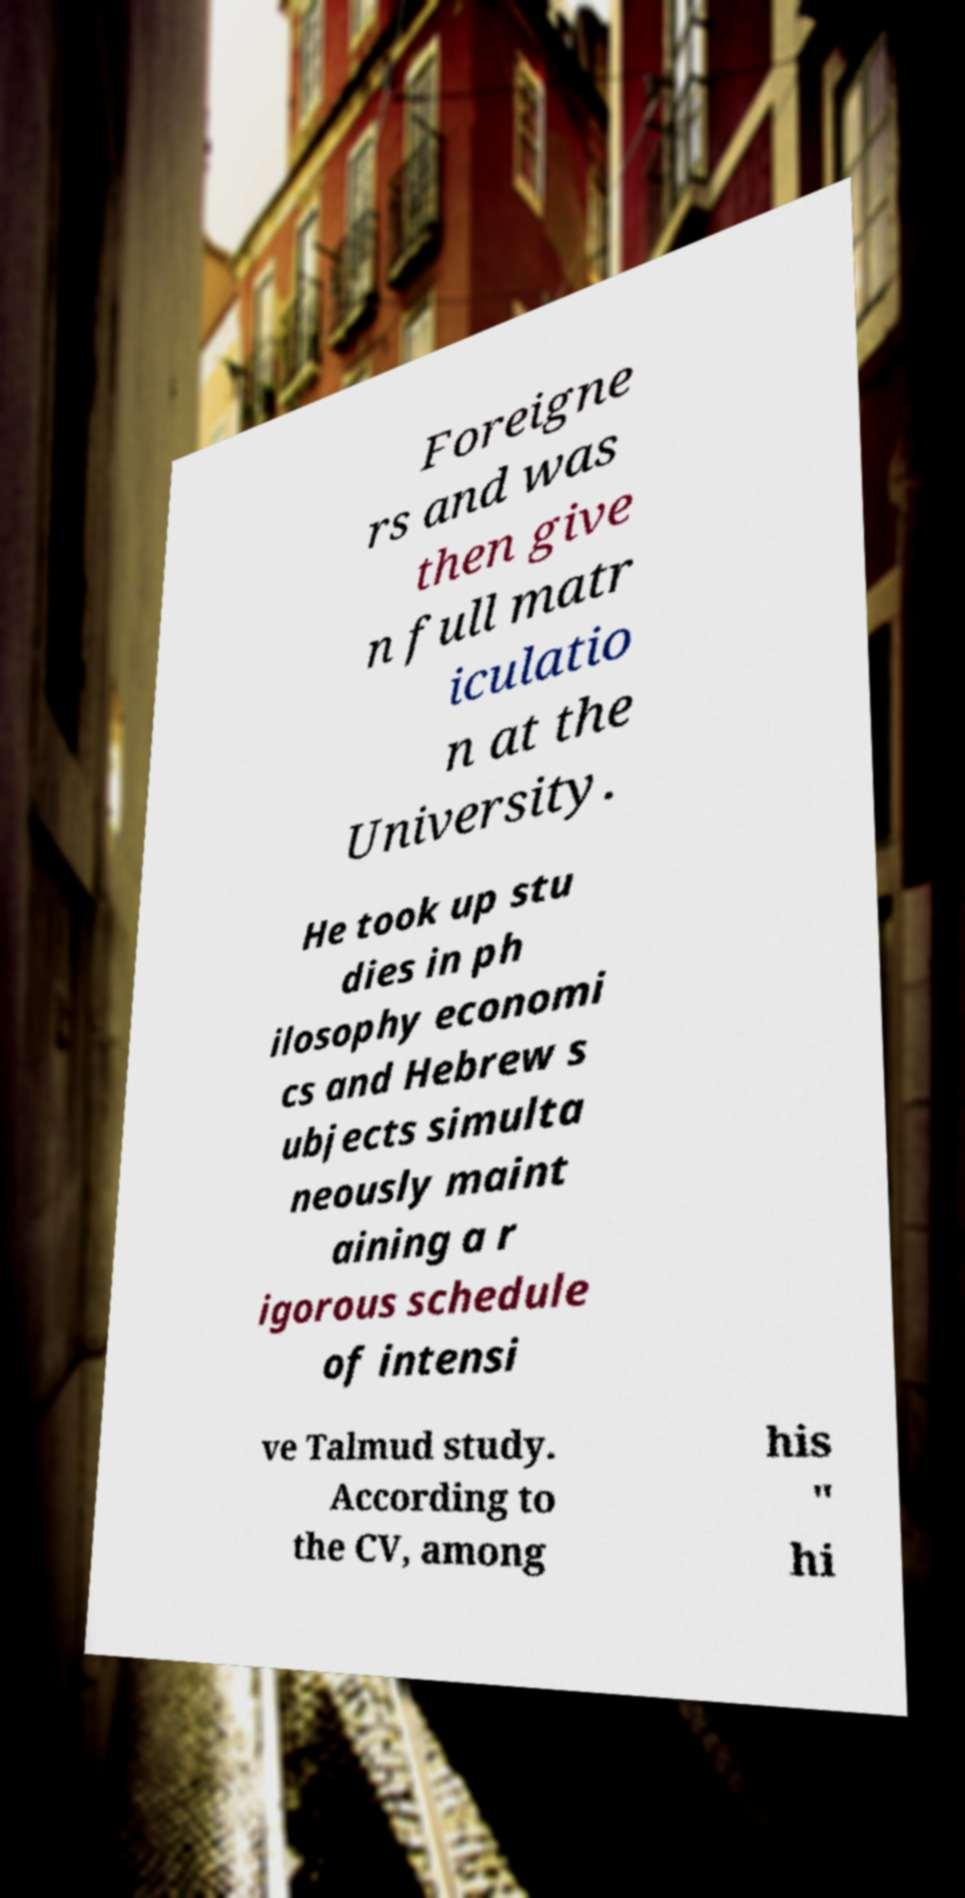For documentation purposes, I need the text within this image transcribed. Could you provide that? Foreigne rs and was then give n full matr iculatio n at the University. He took up stu dies in ph ilosophy economi cs and Hebrew s ubjects simulta neously maint aining a r igorous schedule of intensi ve Talmud study. According to the CV, among his " hi 